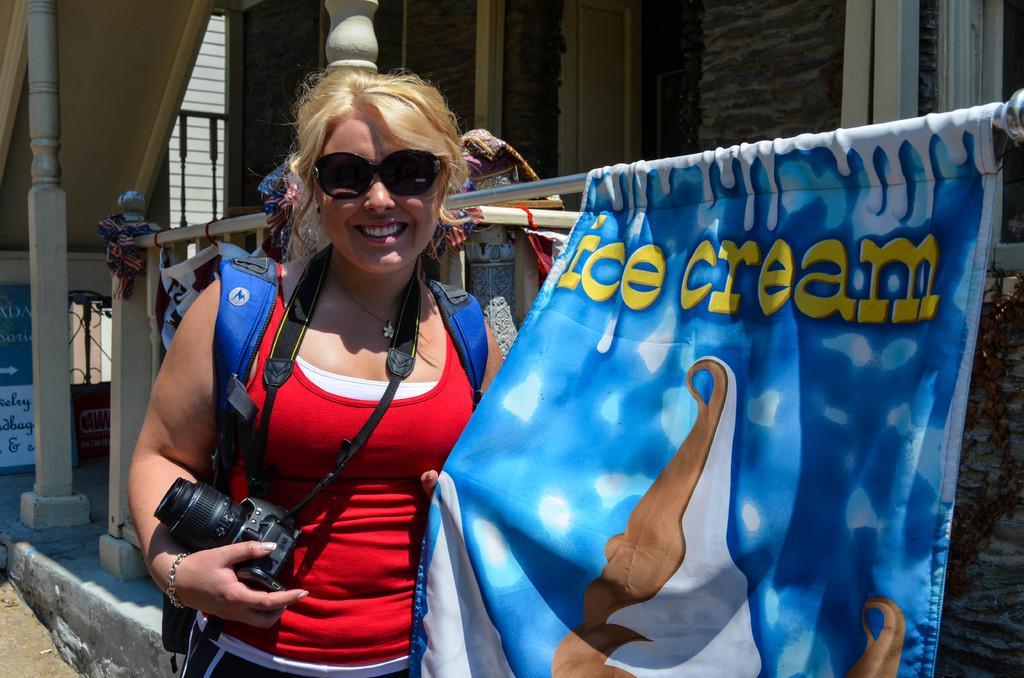Could you give a brief overview of what you see in this image? On the right side we can see a sign board directing towards right side. In foreground we can see a lady wearing red color t-shirt , holding a camera and backpack and wearing goggles. On the left side we can see a flag on which a text like ice cream. On top of the image we can see a door and a window. 